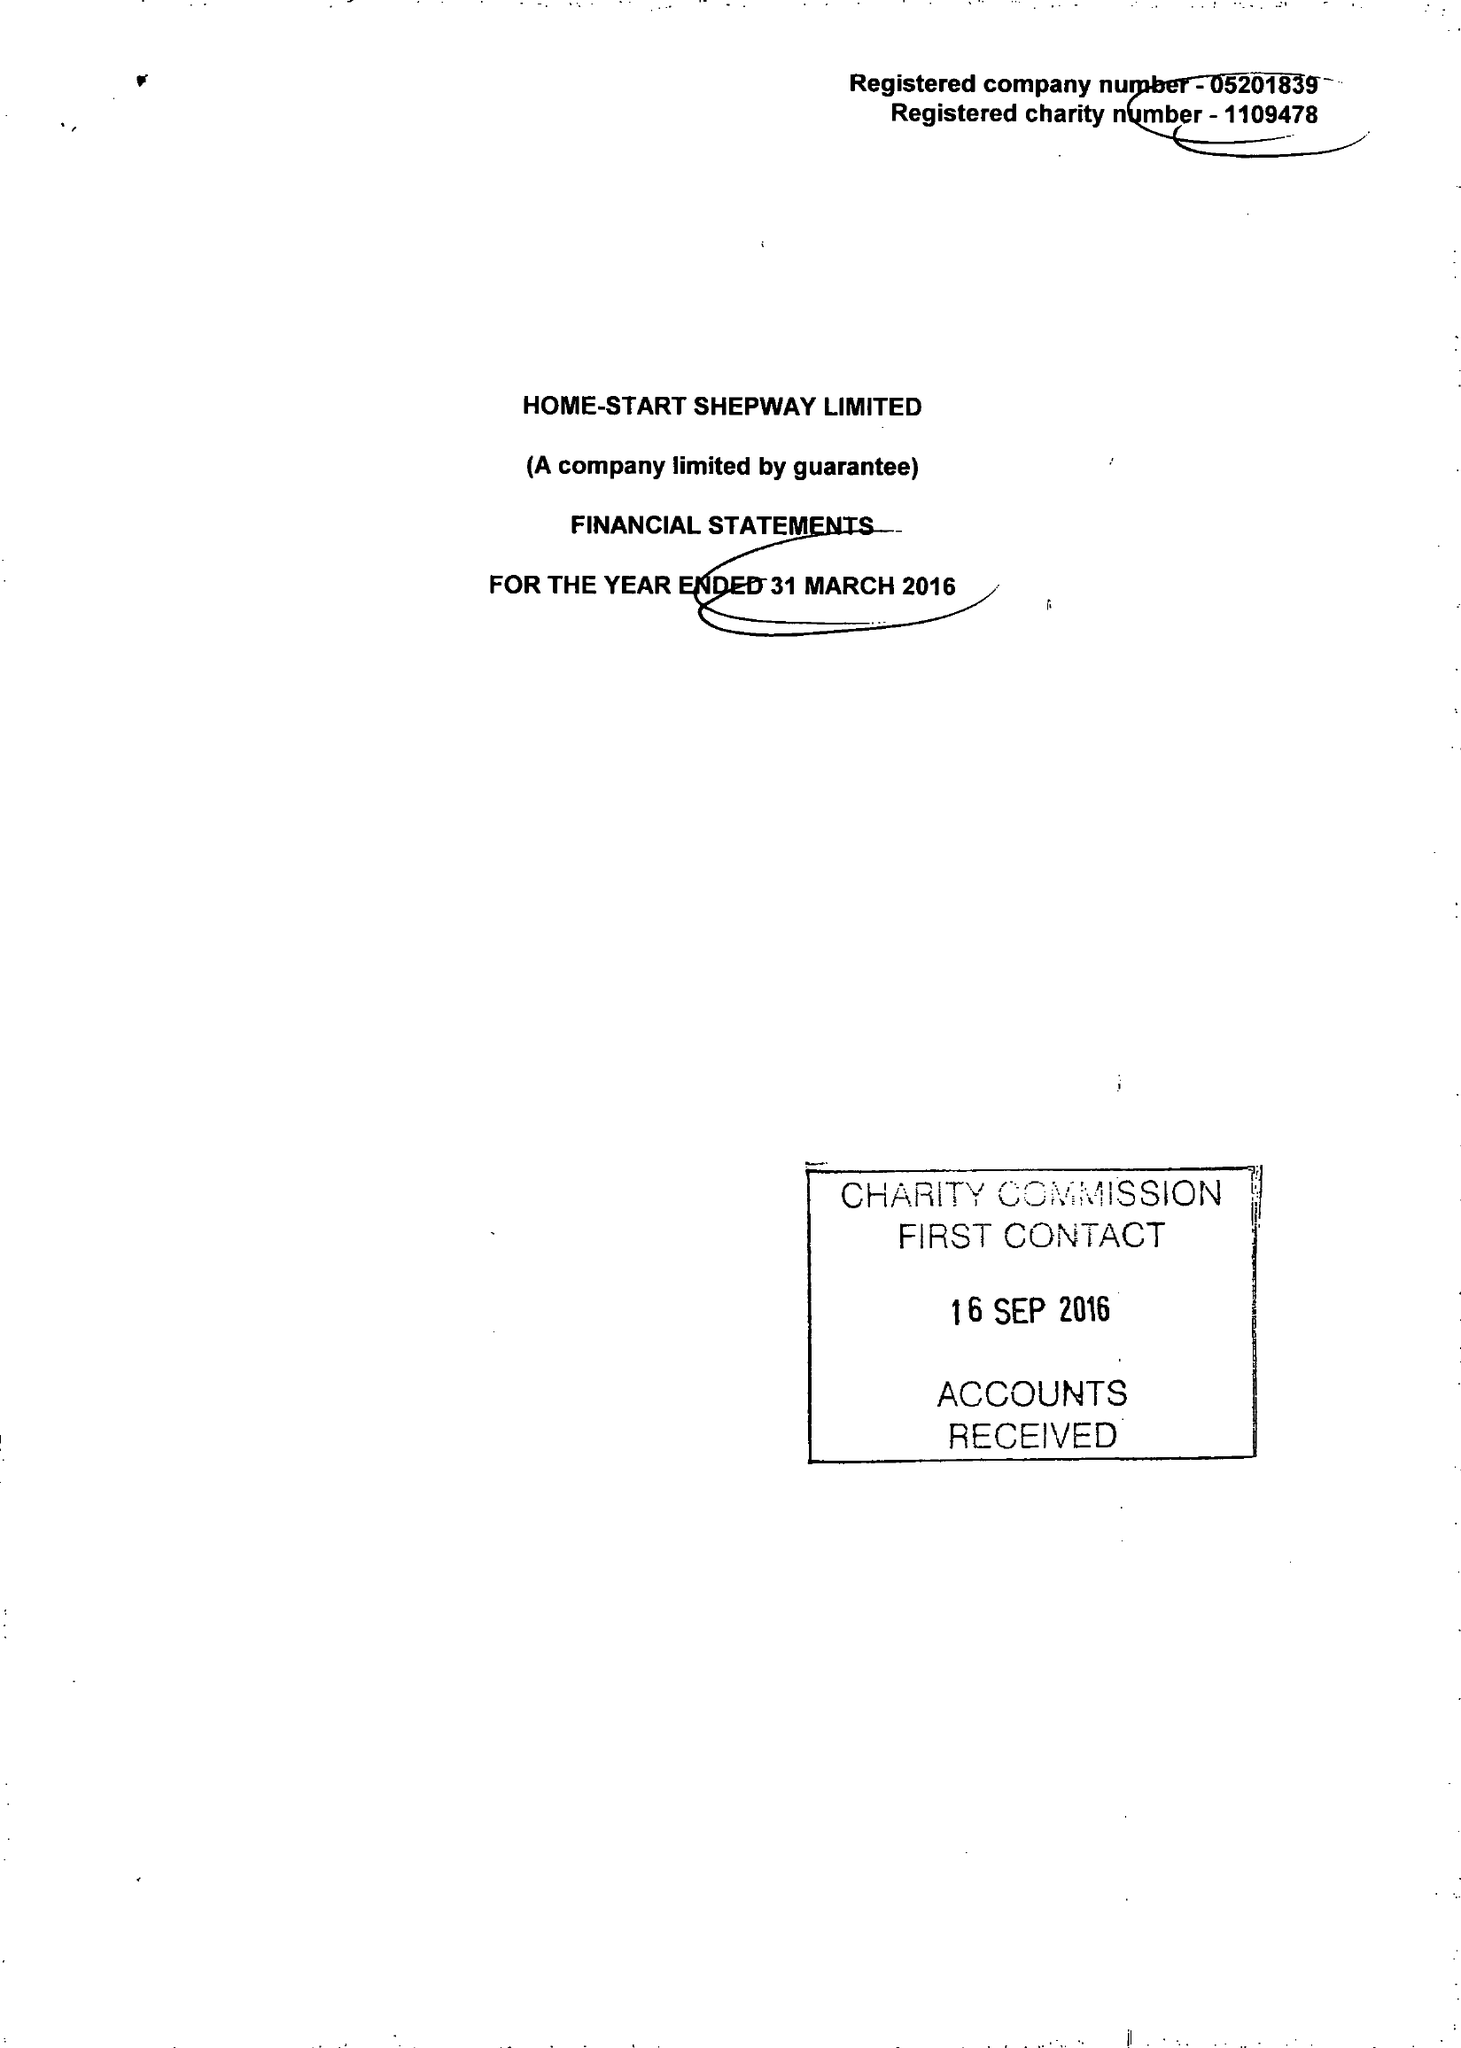What is the value for the charity_name?
Answer the question using a single word or phrase. Home-Start Shepway Ltd. 